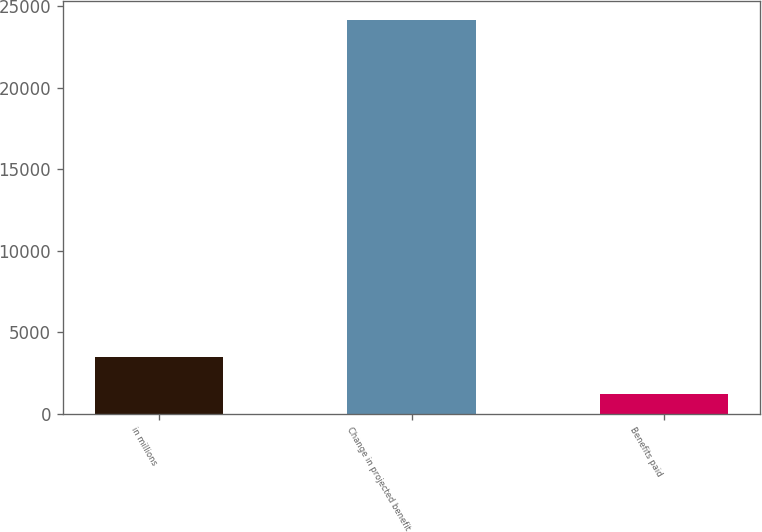Convert chart. <chart><loc_0><loc_0><loc_500><loc_500><bar_chart><fcel>in millions<fcel>Change in projected benefit<fcel>Benefits paid<nl><fcel>3510.9<fcel>24129<fcel>1220<nl></chart> 